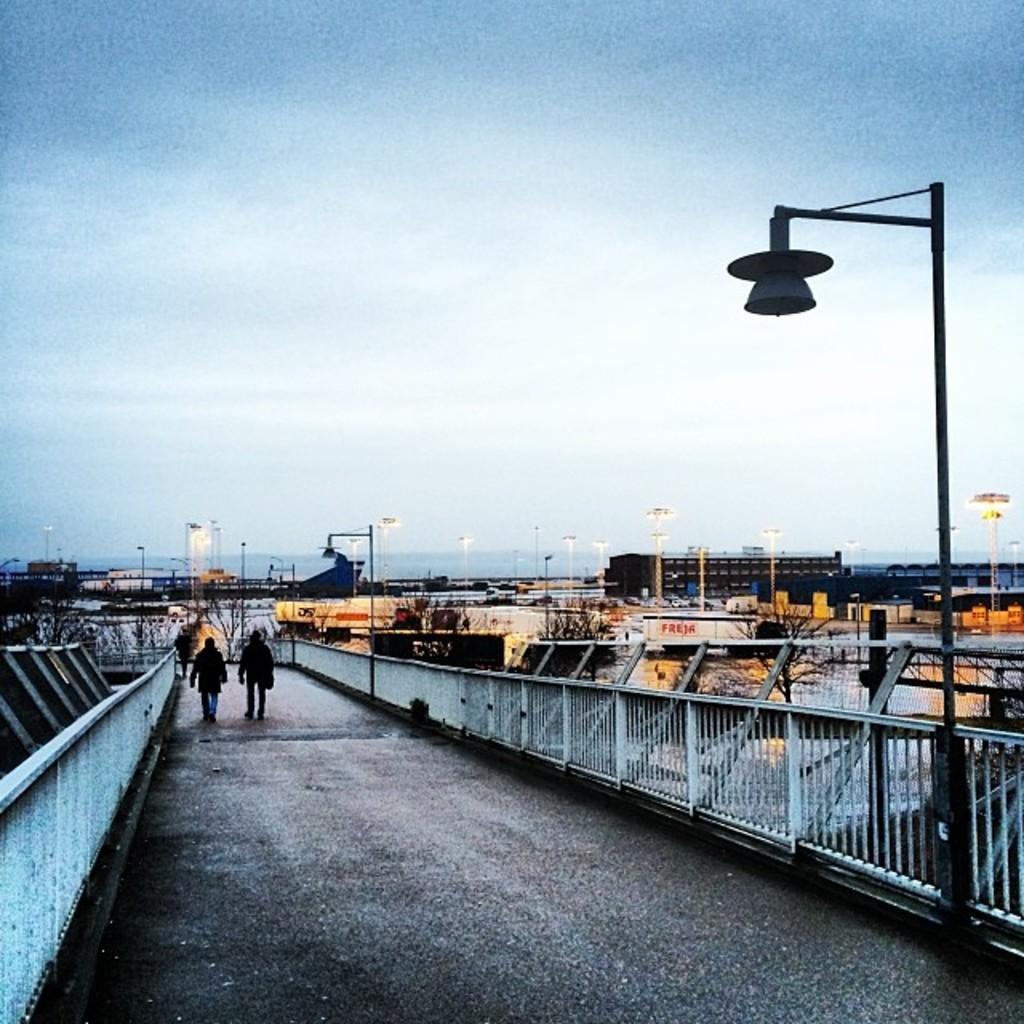Describe this image in one or two sentences. In the center of the image we can see two people are walking on the road. In the background of the image we can see the buildings, lights, poles, bridge, railing, trees. At the top of the image we can see the sky. 